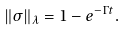<formula> <loc_0><loc_0><loc_500><loc_500>\left \| \sigma \right \| _ { \lambda } = 1 - e ^ { - \Gamma t } .</formula> 